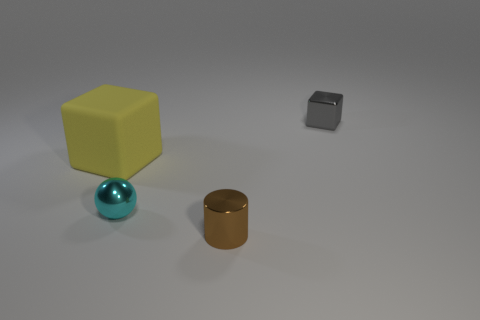Subtract all yellow cubes. How many cubes are left? 1 Subtract all spheres. How many objects are left? 3 Subtract 1 spheres. How many spheres are left? 0 Subtract all red cylinders. Subtract all cyan balls. How many cylinders are left? 1 Subtract all green cylinders. How many gray cubes are left? 1 Subtract all tiny cyan metal things. Subtract all yellow matte blocks. How many objects are left? 2 Add 3 tiny balls. How many tiny balls are left? 4 Add 4 tiny metal things. How many tiny metal things exist? 7 Add 1 big cylinders. How many objects exist? 5 Subtract 1 cyan spheres. How many objects are left? 3 